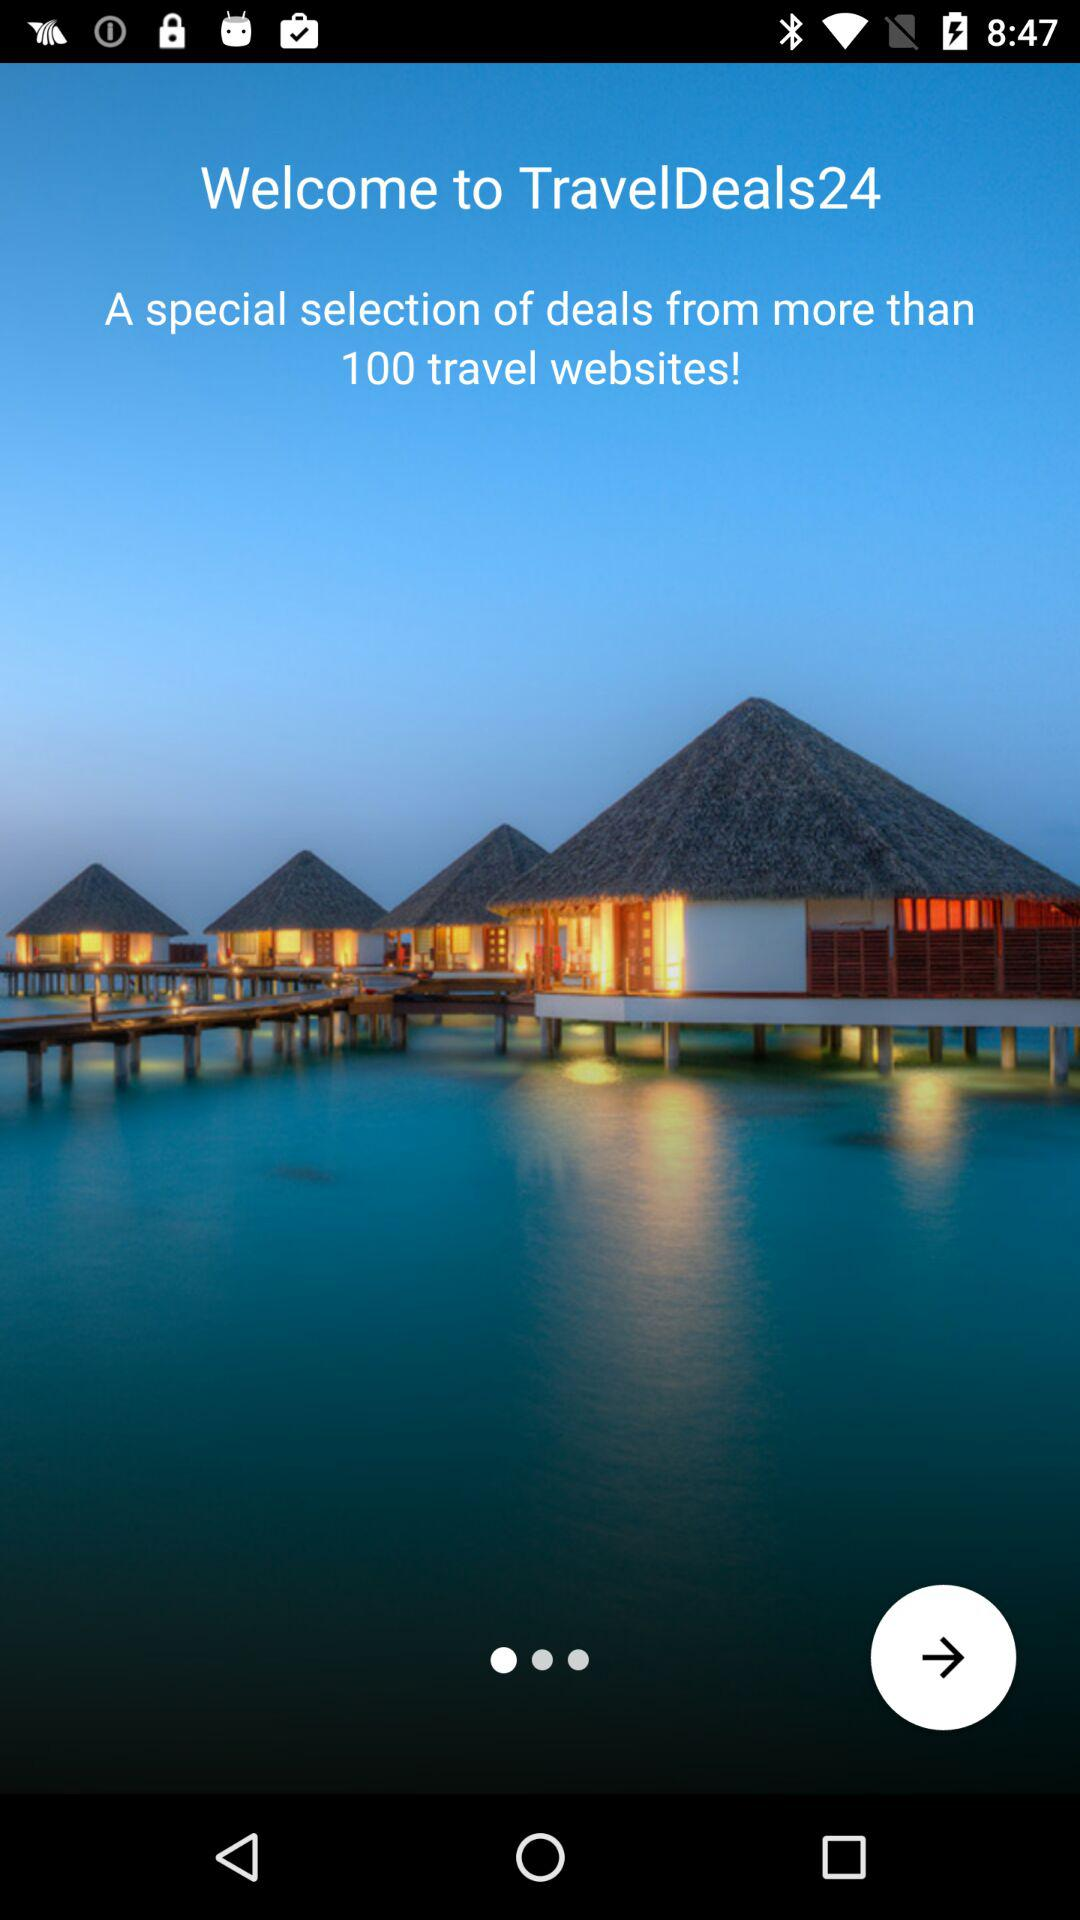How many travel websites in total are there? There are more than 100 travel websites in total. 